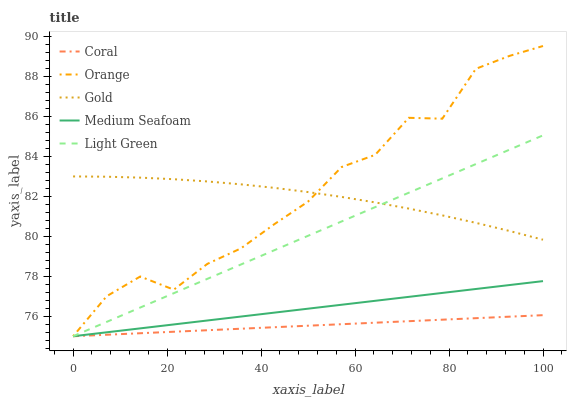Does Coral have the minimum area under the curve?
Answer yes or no. Yes. Does Orange have the maximum area under the curve?
Answer yes or no. Yes. Does Light Green have the minimum area under the curve?
Answer yes or no. No. Does Light Green have the maximum area under the curve?
Answer yes or no. No. Is Coral the smoothest?
Answer yes or no. Yes. Is Orange the roughest?
Answer yes or no. Yes. Is Light Green the smoothest?
Answer yes or no. No. Is Light Green the roughest?
Answer yes or no. No. Does Orange have the lowest value?
Answer yes or no. Yes. Does Gold have the lowest value?
Answer yes or no. No. Does Orange have the highest value?
Answer yes or no. Yes. Does Light Green have the highest value?
Answer yes or no. No. Is Coral less than Gold?
Answer yes or no. Yes. Is Gold greater than Medium Seafoam?
Answer yes or no. Yes. Does Light Green intersect Coral?
Answer yes or no. Yes. Is Light Green less than Coral?
Answer yes or no. No. Is Light Green greater than Coral?
Answer yes or no. No. Does Coral intersect Gold?
Answer yes or no. No. 